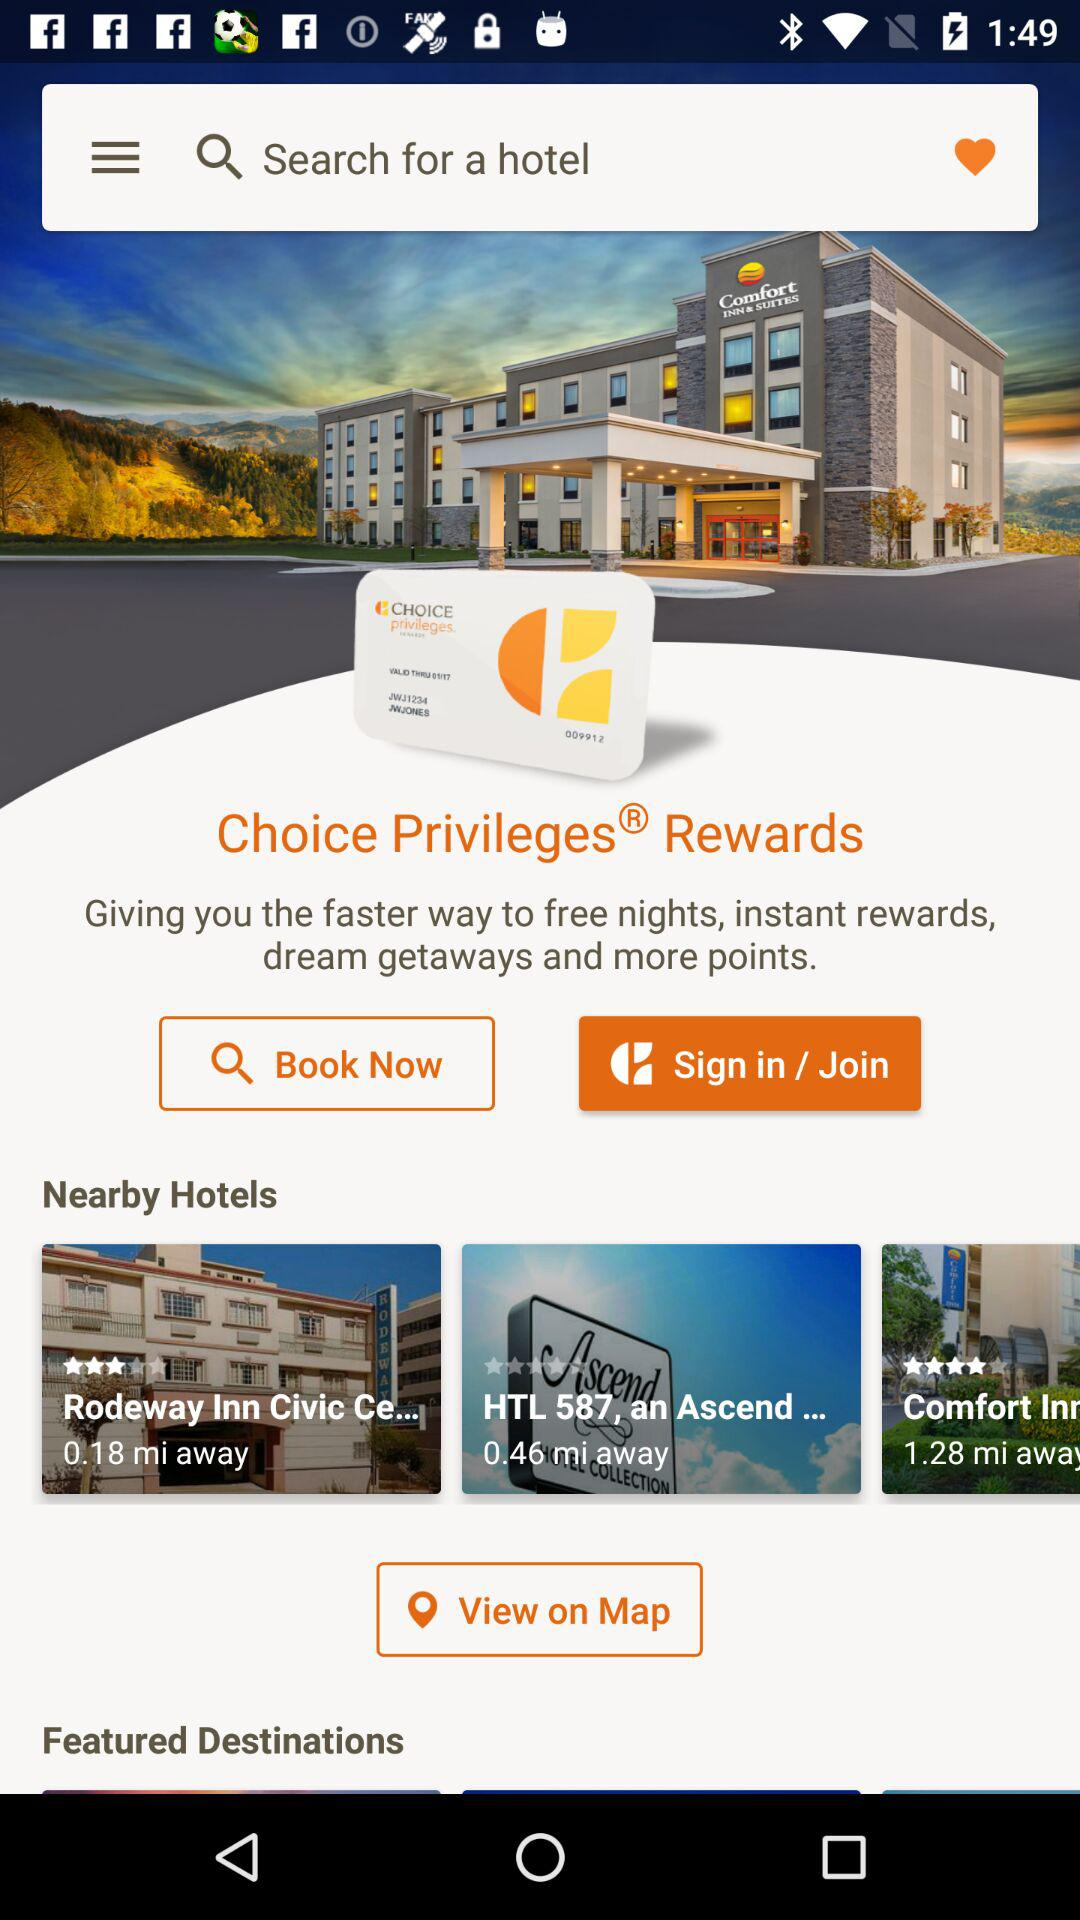What is the rating for the "Comfort Inn" hotel? The rating is 4 stars. 